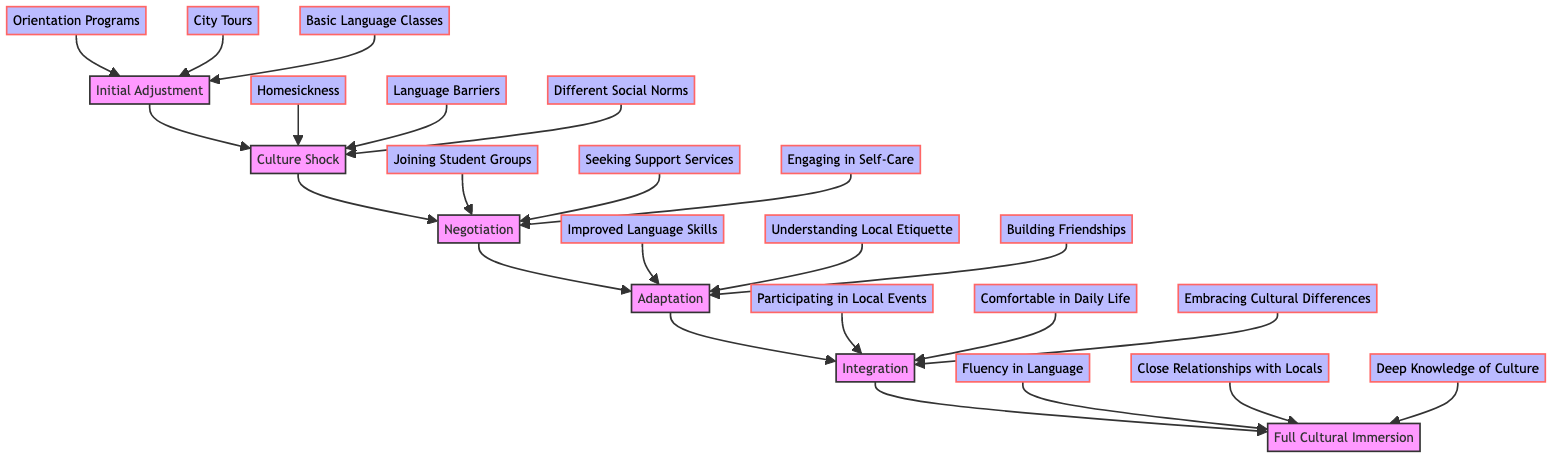What is the first stage of cultural adjustment? The flow chart indicates that the first stage is "Initial Adjustment," which is positioned at the bottom and represents the starting point of cultural adjustment.
Answer: Initial Adjustment How many stages are depicted in the flow chart? The diagram shows a total of six stages, which are: Initial Adjustment, Culture Shock, Negotiation, Adaptation, Integration, and Full Cultural Immersion.
Answer: 6 What activities are associated with the "Initial Adjustment" stage? The chart lists three activities related to the "Initial Adjustment" stage: Orientation Programs, City Tours, and Basic Language Classes, which signify the activities undertaken at this stage.
Answer: Orientation Programs, City Tours, Basic Language Classes What challenges are encountered during "Culture Shock"? The flow chart outlines three challenges faced during the "Culture Shock" stage: Homesickness, Language Barriers, and Different Social Norms which are identified as significant obstacles in adapting to a new culture.
Answer: Homesickness, Language Barriers, Different Social Norms What strategies can help in the "Negotiation" stage? During the "Negotiation" stage, the strategies include Joining Student Groups, Seeking Support Services, and Engaging in Self-Care, which offer methods to cope with adjustment difficulties.
Answer: Joining Student Groups, Seeking Support Services, Engaging in Self-Care What signs indicate someone is in the "Integration" stage? In the "Integration" stage, the signs include Participating in Local Events, Feeling Comfortable in Daily Life, and Embracing Cultural Differences, which show improvement in cultural adaptation.
Answer: Participating in Local Events, Comfortable in Daily Life, Embracing Cultural Differences What is the final outcome of achieving "Full Cultural Immersion"? The chart indicates that the evidences of reaching "Full Cultural Immersion" include Fluency in Language, Close Relationships with Locals, and Deep Knowledge of Culture, representing the culmination of cultural adjustment.
Answer: Fluency in Language, Close Relationships with Locals, Deep Knowledge of Culture How do the stages progress in the diagram? The stages flow from the bottom to the top, indicating that one must go through each stage in sequence, starting from Initial Adjustment and culminating in Full Cultural Immersion.
Answer: From bottom to top What can be inferred about the relationship between "Adaptation" and "Integration"? "Adaptation" serves as a prerequisite for "Integration," meaning one should successfully adapt by building friendships and understanding etiquette to then fully integrate by participating in local events and feeling comfortable with differences.
Answer: Adaptation leads to Integration 